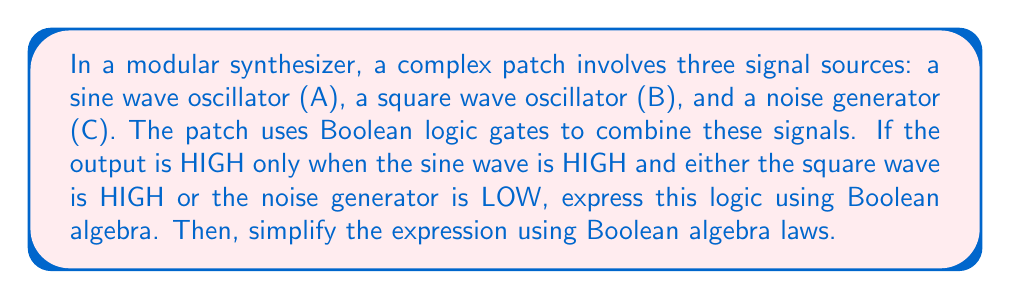Teach me how to tackle this problem. Let's approach this step-by-step:

1) First, we need to translate the given conditions into a Boolean expression:
   - A represents the sine wave (HIGH or LOW)
   - B represents the square wave (HIGH or LOW)
   - C represents the noise generator (HIGH or LOW)

   The output is HIGH when:
   (A is HIGH) AND (B is HIGH OR C is LOW)

2) We can express this in Boolean algebra as:
   $$ Y = A \cdot (B + \overline{C}) $$

3) To simplify this expression, we can use the distributive law of Boolean algebra:
   $$ Y = A \cdot B + A \cdot \overline{C} $$

4) This expression cannot be simplified further without additional information about the relationships between A, B, and C.

5) In the context of electronic music synthesis, this Boolean operation could be implemented using AND and OR gates, with an inverter (NOT gate) for the C input.

6) The resulting circuit would combine the sine wave with either the square wave or the inverted noise signal, creating a complex modulation pattern typical in experimental electronic music compositions.
Answer: $$ A \cdot B + A \cdot \overline{C} $$ 